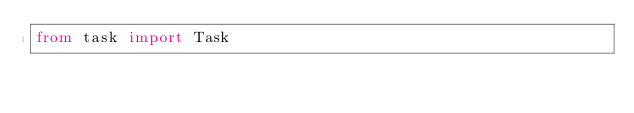<code> <loc_0><loc_0><loc_500><loc_500><_Python_>from task import Task
</code> 